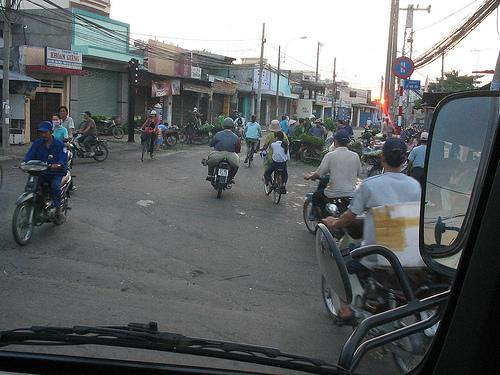How many people are wearing blue clothing or accessories in this image? Five people are wearing blue clothing or accessories in the image. Mention three different types of headwear present in the image. Blue hat, pink hat, and gray helmet. Provide a brief overview of the location in the image. The image features a bustling shopping district with store fronts, people in the street, and various means of transportation. Count the number of persons riding bicycles in the image. Four persons are riding bicycles in the image. Identify an object in the image related to traffic signage and its colors. A traffic sign with red and blue lines is present on the street. What is the main activity happening on the street in the image? People are riding bicycles, motorcycles and walking in a busy city street. Briefly explain the scene involving a person wearing a pink hat. A person wearing a pink hat is riding a bicycle in the busy street among other people. Describe the environment of the street. The street is a busy city street with various people, store fronts, bicycles, and mopeds. There's a shopping district, and the road is tarmacked. What type of object is next to the person with a blue hat, and what color is it? A person wearing a white hat is next to the person with a blue hat. What type of mirror can you see on a vehicle in the image? A circular side view mirror can be seen on a vehicle in the image. Identify a kitten playing near the brown and white bag. There is no mention of a kitten in the given image information, and the instruction is misleading as it asks the user to find an object that is not present in the image. Try to find an old man reading a newspaper on a bench. There is no mention of an old man or a bench in the given image information, and the instruction is misleading as it asks the user to locate objects that don't exist in the image. Look for a giant yellow umbrella near the store fronts. There is no mention of an umbrella in the given image information, and the instruction is misleading as it asks the user to search for an object that doesn't exist in the image. Can you find the green dog in the image? There is no mention of a dog in the given image information, and the instruction is misleading as it asks the user to find an object that doesn't exist. Spot the orange airplane flying above the people on bicycles. There is no mention of an airplane in the given image information, and the instruction is misleading as it requests the user to find an object that is not present in the image. Is there a purple graffiti on the gray helmet or any building in the image? There is no mention of any graffiti in the given image information. The instruction misleads the user by asking them to find details that do not exist in the image. 